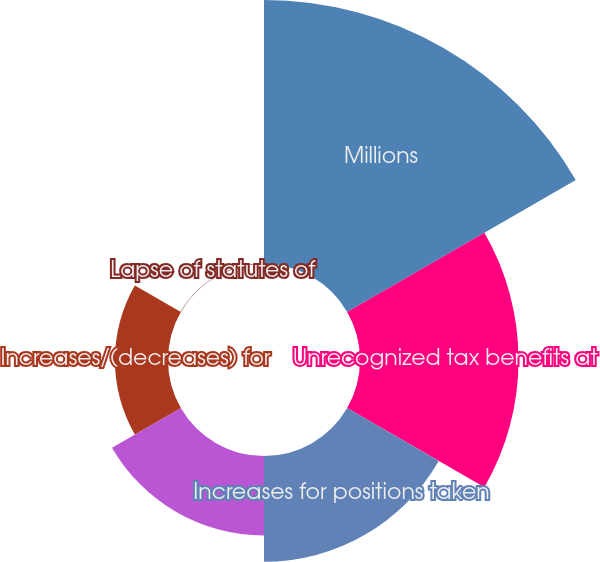Convert chart. <chart><loc_0><loc_0><loc_500><loc_500><pie_chart><fcel>Millions<fcel>Unrecognized tax benefits at<fcel>Increases for positions taken<fcel>Decreases for positions taken<fcel>Increases/(decreases) for<fcel>Lapse of statutes of<nl><fcel>39.92%<fcel>23.97%<fcel>16.0%<fcel>12.02%<fcel>8.03%<fcel>0.06%<nl></chart> 